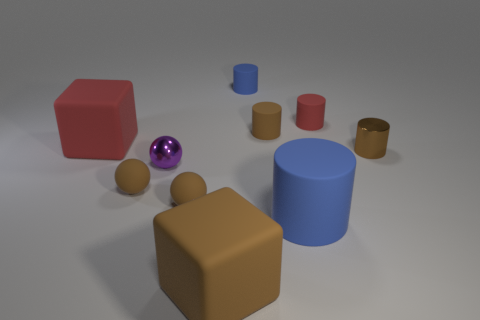What shape is the small red thing?
Give a very brief answer. Cylinder. What is the size of the rubber block in front of the red matte thing that is left of the large brown block?
Provide a short and direct response. Large. How many things are large blue rubber cubes or shiny objects?
Give a very brief answer. 2. Is the shape of the big brown matte object the same as the big red thing?
Provide a short and direct response. Yes. Are there any purple things that have the same material as the big red block?
Ensure brevity in your answer.  No. Is there a small red thing that is to the left of the brown cylinder behind the big red rubber thing?
Your answer should be compact. No. Is the size of the blue thing in front of the red matte cylinder the same as the red rubber cube?
Make the answer very short. Yes. The red cube has what size?
Offer a very short reply. Large. Are there any matte objects of the same color as the large rubber cylinder?
Provide a succinct answer. Yes. What number of tiny things are either balls or red things?
Offer a very short reply. 4. 